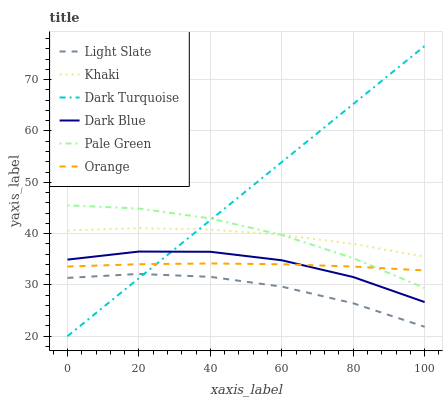Does Light Slate have the minimum area under the curve?
Answer yes or no. Yes. Does Dark Turquoise have the maximum area under the curve?
Answer yes or no. Yes. Does Dark Turquoise have the minimum area under the curve?
Answer yes or no. No. Does Light Slate have the maximum area under the curve?
Answer yes or no. No. Is Dark Turquoise the smoothest?
Answer yes or no. Yes. Is Dark Blue the roughest?
Answer yes or no. Yes. Is Light Slate the smoothest?
Answer yes or no. No. Is Light Slate the roughest?
Answer yes or no. No. Does Light Slate have the lowest value?
Answer yes or no. No. Does Dark Turquoise have the highest value?
Answer yes or no. Yes. Does Light Slate have the highest value?
Answer yes or no. No. Is Dark Blue less than Pale Green?
Answer yes or no. Yes. Is Orange greater than Light Slate?
Answer yes or no. Yes. Does Dark Blue intersect Dark Turquoise?
Answer yes or no. Yes. Is Dark Blue less than Dark Turquoise?
Answer yes or no. No. Is Dark Blue greater than Dark Turquoise?
Answer yes or no. No. Does Dark Blue intersect Pale Green?
Answer yes or no. No. 